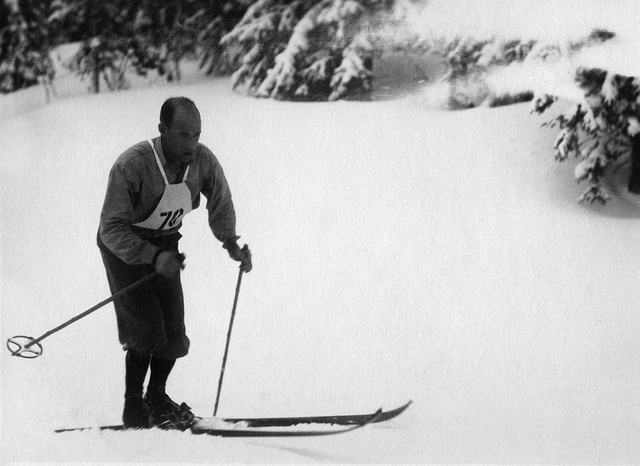Describe the objects in this image and their specific colors. I can see people in black, gray, and lightgray tones and skis in black, lightgray, gray, and darkgray tones in this image. 